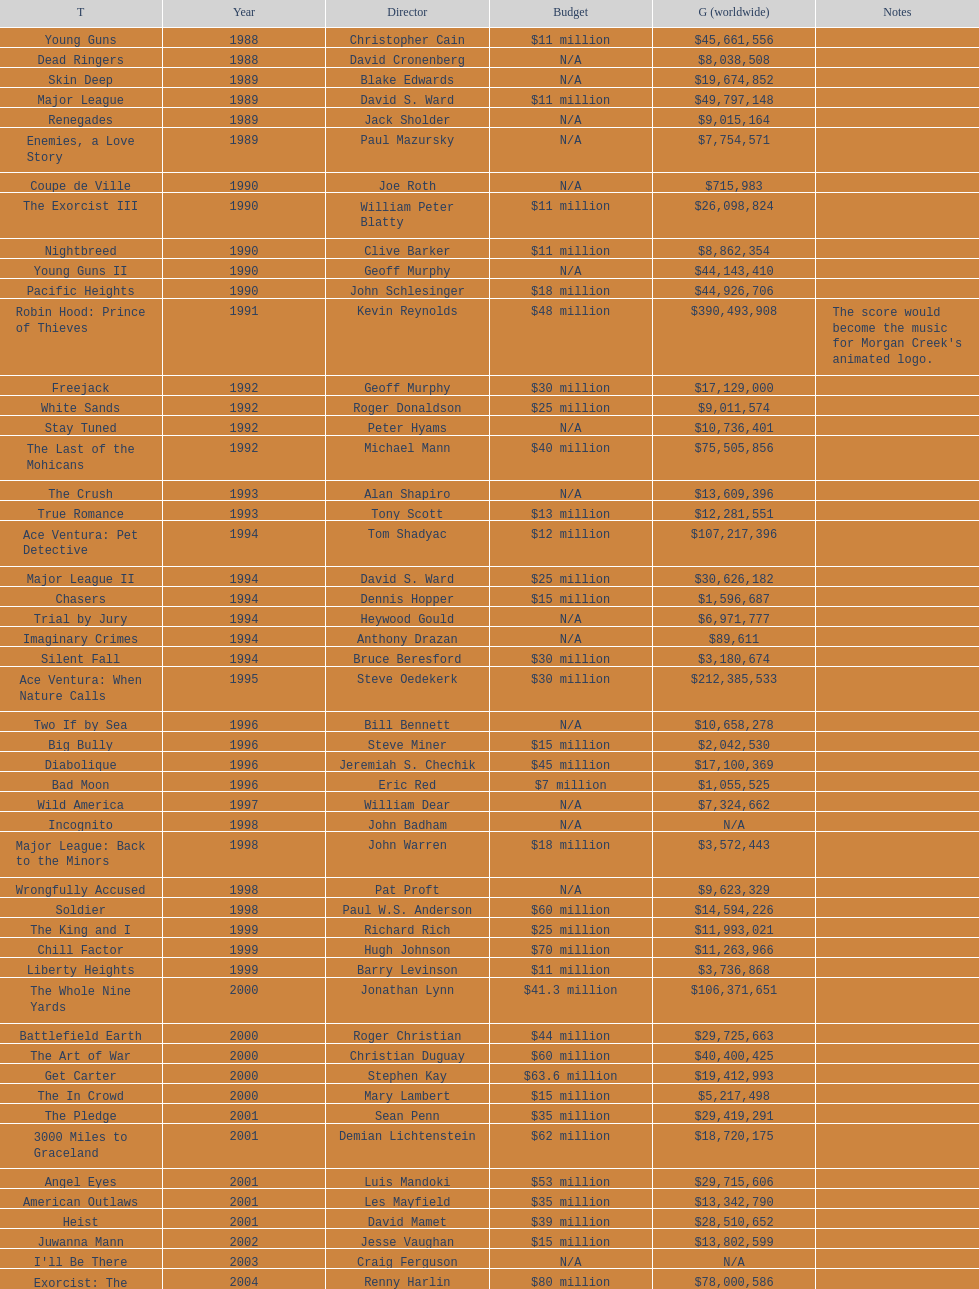What movie was made immediately before the pledge? The In Crowd. 